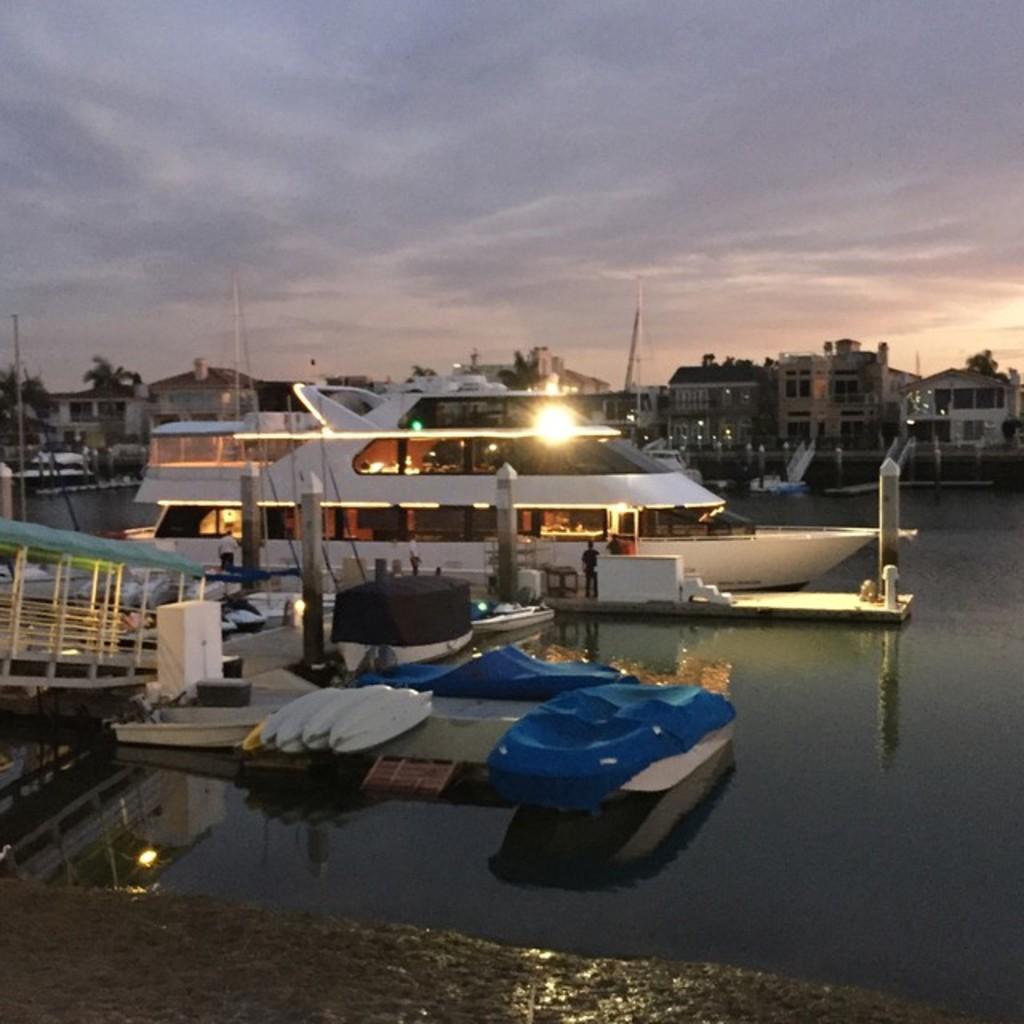Please provide a concise description of this image. In the foreground of this image, there are few boats and a ship near a dock. In the background, there is a ship on the water, few buildings, sky and the cloud. 